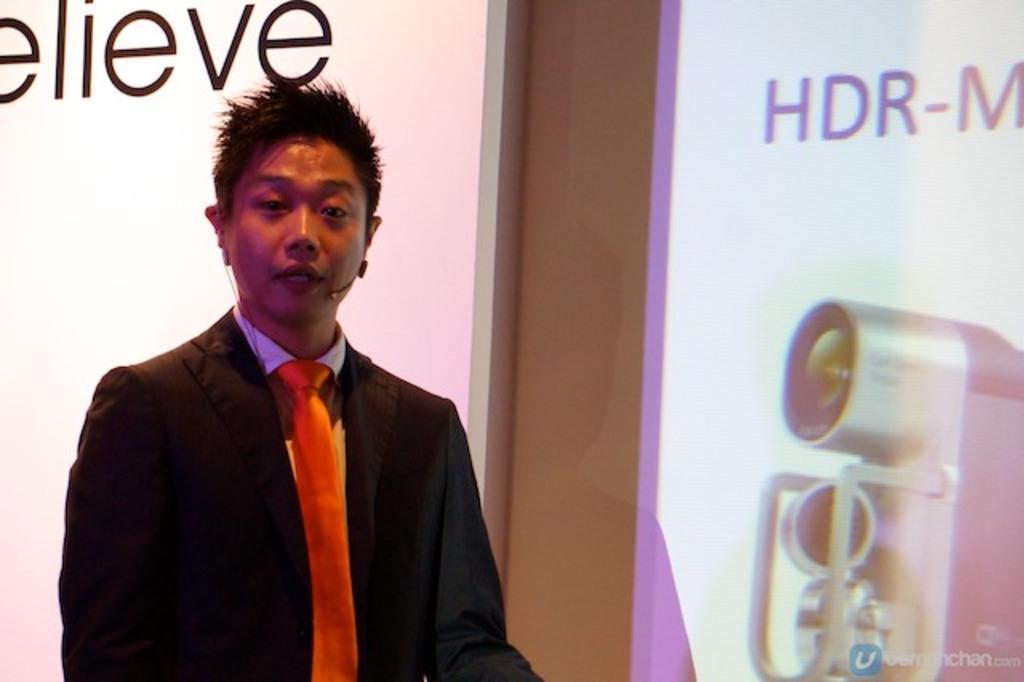Describe this image in one or two sentences. In this picture the man is highlighted. I think he is speaking in a mic, as we can see his mouth is open. He wore black suit, red tie. Background of him there is a banner in white color. There is a another banner in white and purple color. On this banner there is one electronic device. 